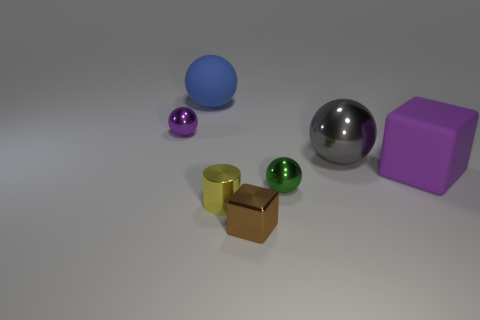Subtract 1 balls. How many balls are left? 3 Add 1 large yellow metal cylinders. How many objects exist? 8 Subtract all cylinders. How many objects are left? 6 Add 2 small purple metal objects. How many small purple metal objects are left? 3 Add 4 small cylinders. How many small cylinders exist? 5 Subtract 0 blue blocks. How many objects are left? 7 Subtract all big shiny balls. Subtract all rubber spheres. How many objects are left? 5 